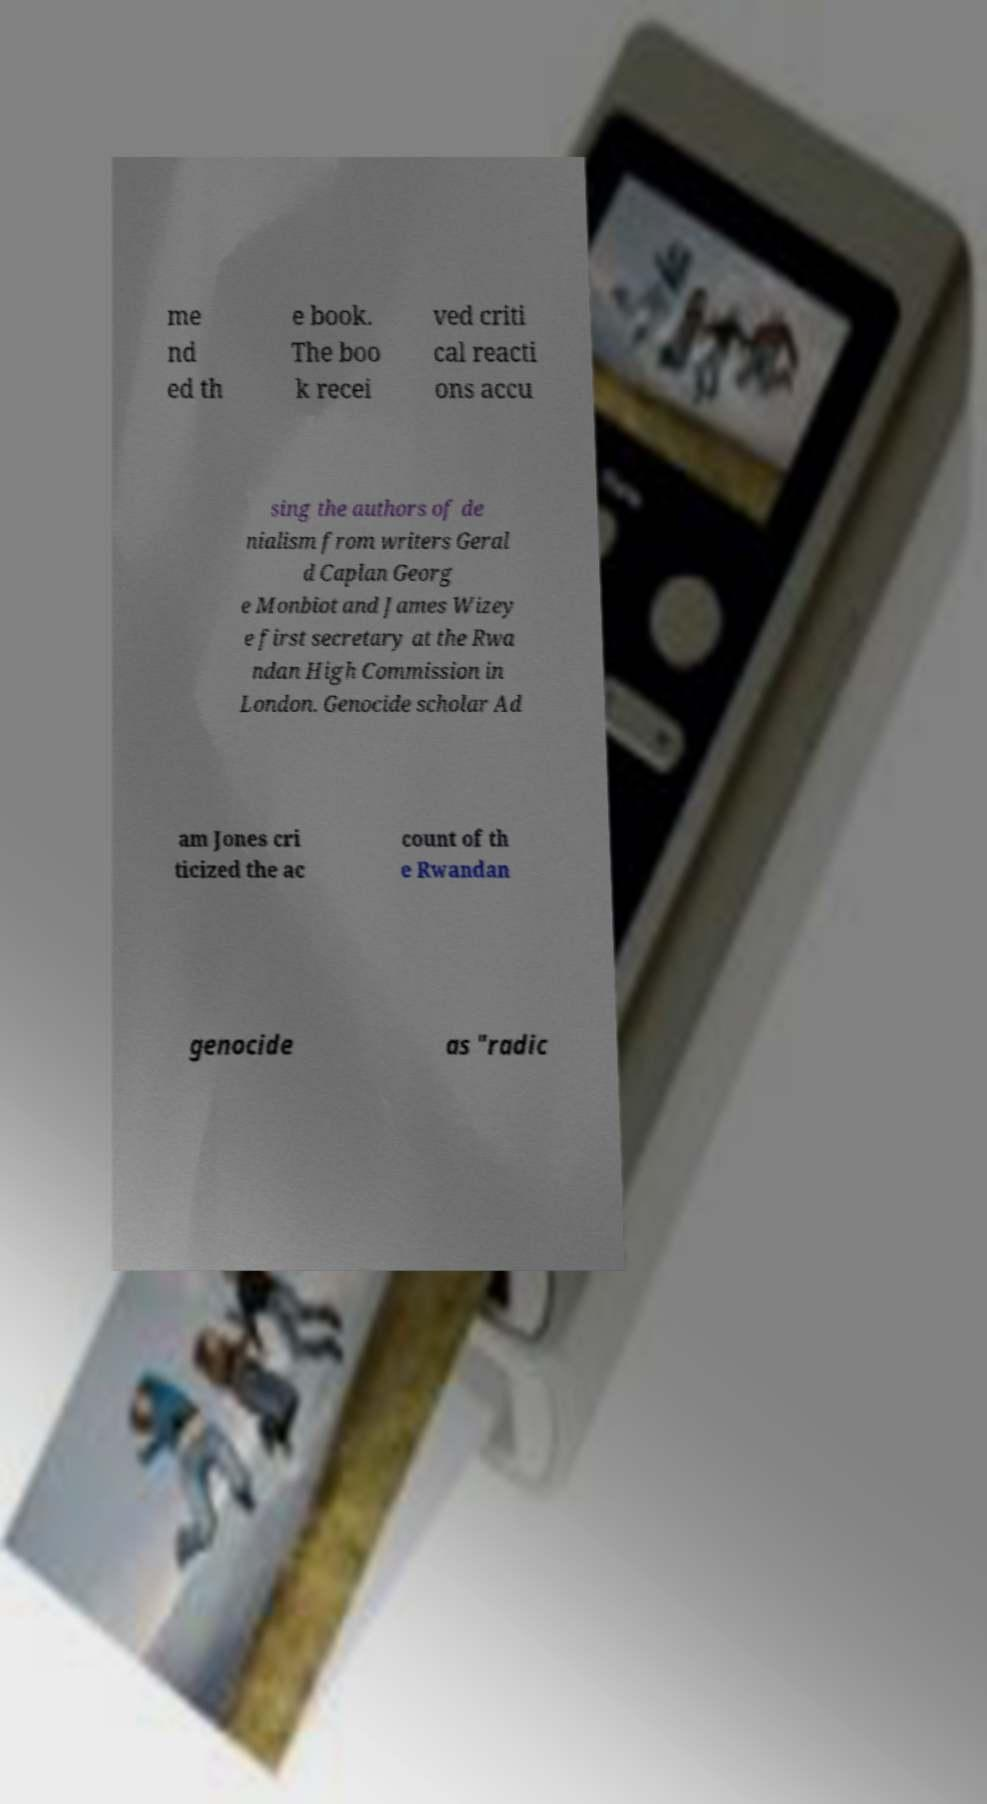Please read and relay the text visible in this image. What does it say? me nd ed th e book. The boo k recei ved criti cal reacti ons accu sing the authors of de nialism from writers Geral d Caplan Georg e Monbiot and James Wizey e first secretary at the Rwa ndan High Commission in London. Genocide scholar Ad am Jones cri ticized the ac count of th e Rwandan genocide as "radic 